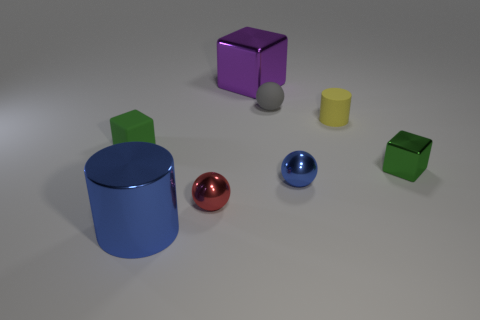What is the shape of the green metal object that is the same size as the yellow cylinder?
Give a very brief answer. Cube. Is there a purple metal cylinder that has the same size as the rubber ball?
Make the answer very short. No. There is a cube that is the same size as the blue cylinder; what is it made of?
Give a very brief answer. Metal. There is a green cube that is right of the big blue metallic cylinder that is to the left of the tiny red shiny object; how big is it?
Your answer should be very brief. Small. Is the size of the green block that is on the left side of the green metal object the same as the green shiny thing?
Your response must be concise. Yes. Is the number of gray spheres that are on the right side of the blue sphere greater than the number of small gray matte objects that are right of the tiny yellow matte cylinder?
Your response must be concise. No. There is a tiny metallic object that is left of the small cylinder and behind the small red metallic sphere; what shape is it?
Provide a succinct answer. Sphere. What shape is the big shiny object that is behind the green rubber block?
Keep it short and to the point. Cube. There is a green object to the right of the green block that is behind the shiny block in front of the gray object; what size is it?
Make the answer very short. Small. Do the yellow object and the tiny green matte thing have the same shape?
Provide a short and direct response. No. 